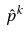<formula> <loc_0><loc_0><loc_500><loc_500>\hat { p } ^ { k }</formula> 